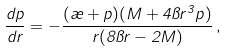<formula> <loc_0><loc_0><loc_500><loc_500>\frac { d p } { d r } = - \frac { ( \rho + p ) ( M + 4 \pi r ^ { 3 } p ) } { r ( 8 \pi r - 2 M ) } \, ,</formula> 